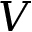Convert formula to latex. <formula><loc_0><loc_0><loc_500><loc_500>V</formula> 